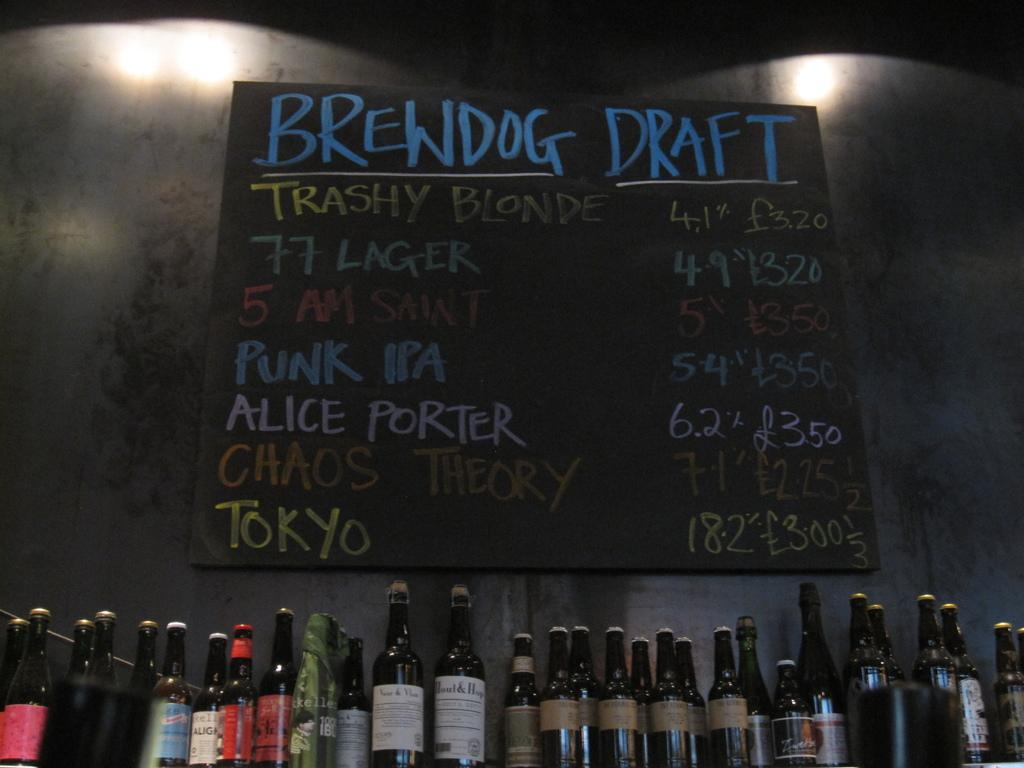<image>
Relay a brief, clear account of the picture shown. The Brewdog Draft menu lists seven different kinds of beer. 